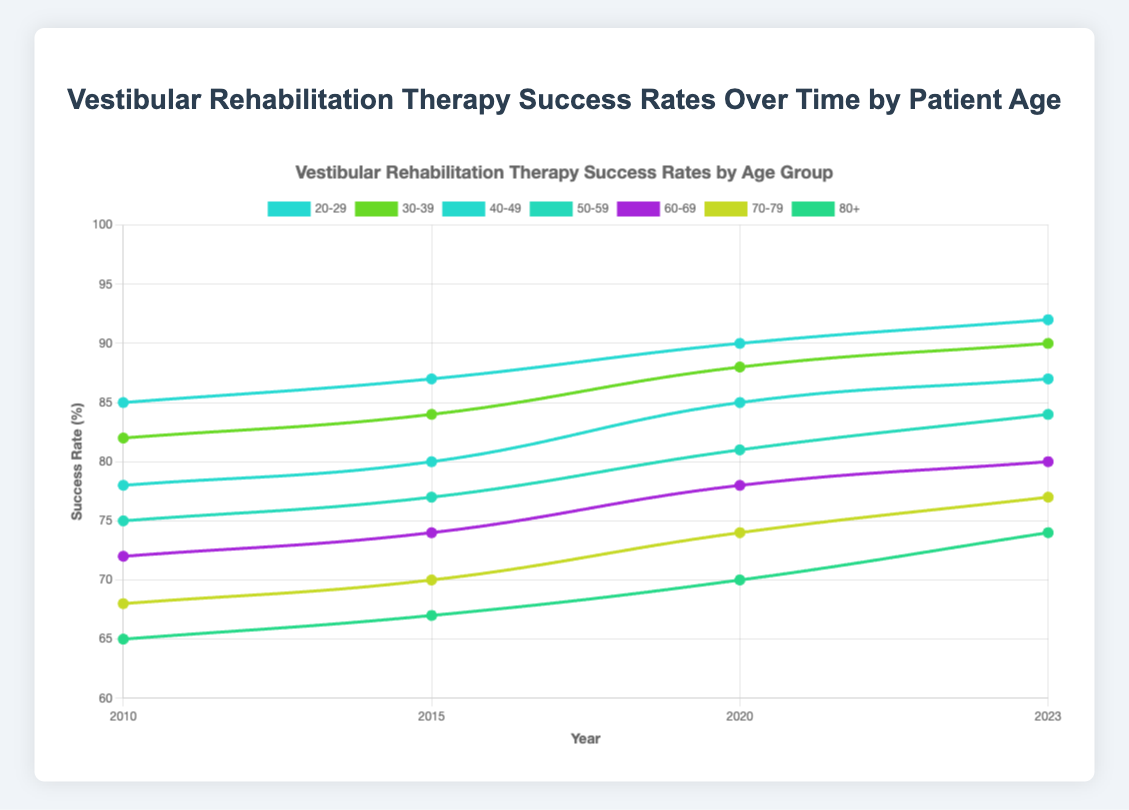What is the average success rate for the 40-49 age group across all years? First, gather the success rates for the 40-49 age group: 78 (2010), 80 (2015), 85 (2020), and 87 (2023). Sum them up: 78 + 80 + 85 + 87 = 330. Divide by the number of years (4): 330 / 4 = 82.5
Answer: 82.5 Which age group saw the greatest increase in success rate from 2010 to 2023? Calculate the difference in success rates for each age group between 2010 and 2023: 
- 20-29: 92 - 85 = 7
- 30-39: 90 - 82 = 8
- 40-49: 87 - 78 = 9
- 50-59: 84 - 75 = 9
- 60-69: 80 - 72 = 8
- 70-79: 77 - 68 = 9
- 80+: 74 - 65 = 9
The age groups 40-49, 50-59, 70-79, and 80+ all saw an increase of 9
Answer: 40-49, 50-59, 70-79, 80+ What is the trend in success rates for the 60-69 age group from 2010 to 2023? Observing the data points for 60-69 over the years: 72 (2010), 74 (2015), 78 (2020), 80 (2023), the trend shows a consistent increase
Answer: Increasing Which age group had the lowest success rate in 2010, and what was the rate? Look at 2010 success rates for all age groups and find the minimum: 85 (20-29), 82 (30-39), 78 (40-49), 75 (50-59), 72 (60-69), 68 (70-79), 65 (80+). The lowest is for the 80+ age group with 65
Answer: 80+ with 65 What is the average success rate for all age groups in 2023? Find the 2023 success rates: 92, 90, 87, 84, 80, 77, 74. Sum: 92 + 90 + 87 + 84 + 80 + 77 + 74 = 584. Divide by the number of groups (7): 584 / 7 ≈ 83.43
Answer: 83.43 Is there any age group whose success rate has remained constant over the years? Compare success rates for each age group over the years (2010, 2015, 2020, 2023). All age groups show an increase over time; hence, no group's success rate is constant
Answer: No 